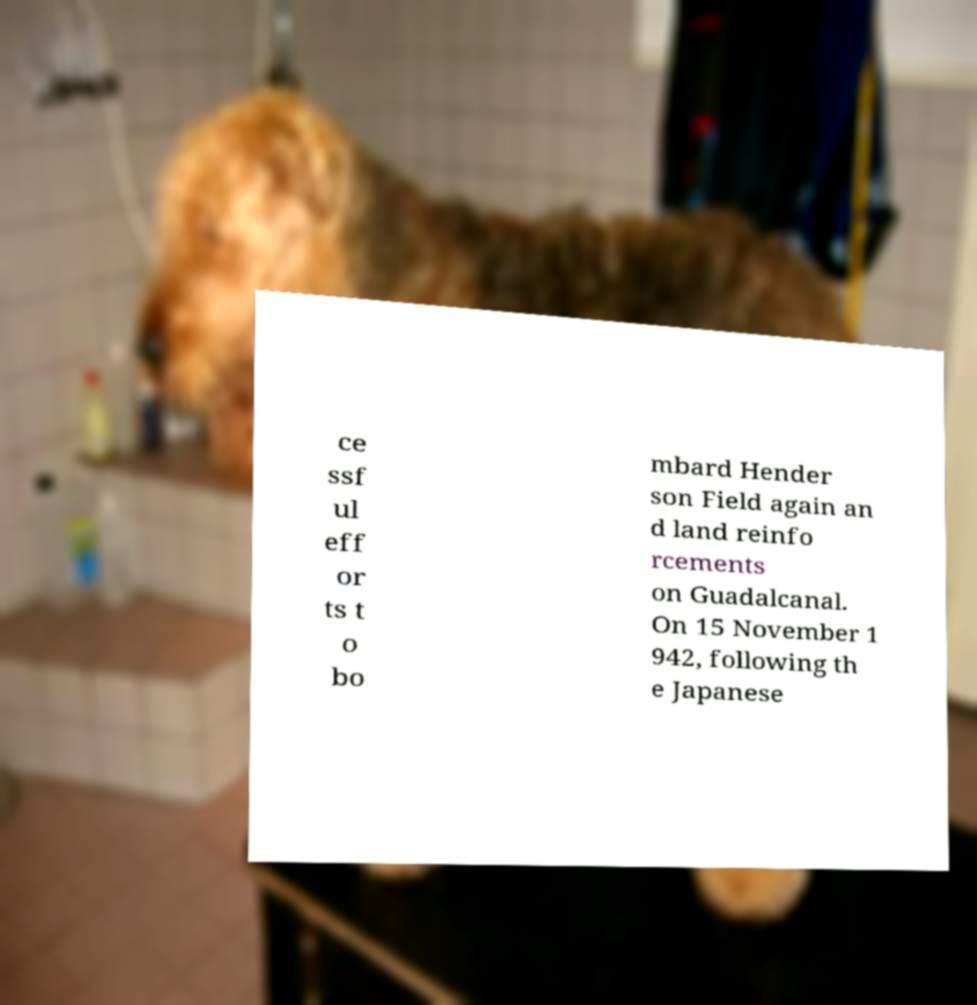Could you assist in decoding the text presented in this image and type it out clearly? ce ssf ul eff or ts t o bo mbard Hender son Field again an d land reinfo rcements on Guadalcanal. On 15 November 1 942, following th e Japanese 